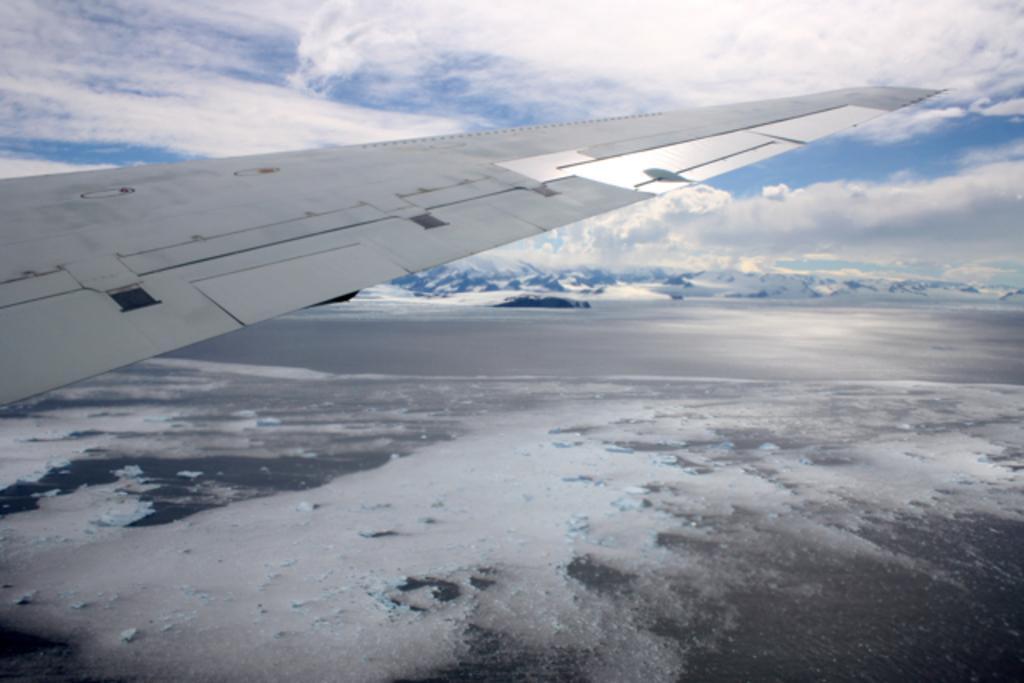Can you describe this image briefly? In this image I can see wing of an airplane. In the background I can see clouds and the sky. 